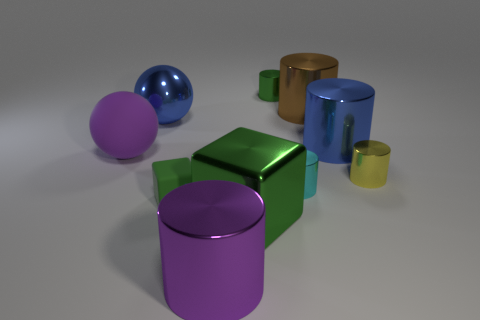How many purple spheres are made of the same material as the cyan thing?
Your response must be concise. 0. What color is the large sphere that is the same material as the cyan cylinder?
Your response must be concise. Blue. There is a green metallic cylinder; is it the same size as the purple object that is right of the purple ball?
Your response must be concise. No. What is the material of the large purple object on the left side of the big cylinder on the left side of the small green object right of the large purple shiny cylinder?
Keep it short and to the point. Rubber. What number of objects are brown things or red rubber balls?
Keep it short and to the point. 1. Is the color of the block that is left of the large purple metallic cylinder the same as the metallic object that is on the left side of the purple metal cylinder?
Make the answer very short. No. There is a purple metallic thing that is the same size as the metal ball; what shape is it?
Offer a very short reply. Cylinder. What number of objects are blue things that are on the right side of the small cyan thing or green objects behind the big block?
Ensure brevity in your answer.  3. Is the number of tiny green cylinders less than the number of small metallic spheres?
Your answer should be very brief. No. There is a block that is the same size as the cyan shiny cylinder; what is its material?
Your response must be concise. Rubber. 